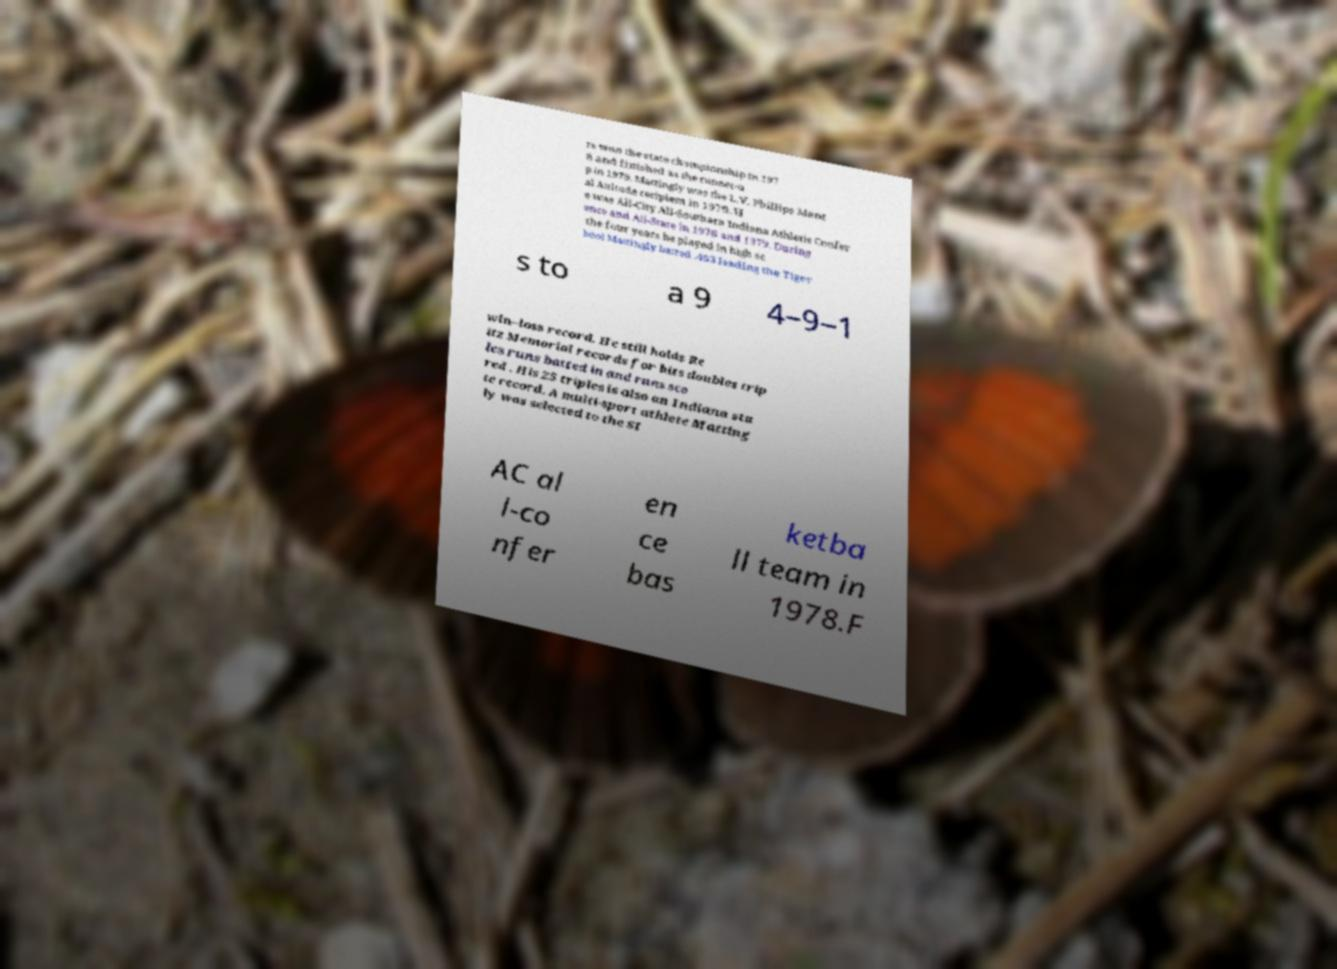For documentation purposes, I need the text within this image transcribed. Could you provide that? rs won the state championship in 197 8 and finished as the runner-u p in 1979. Mattingly was the L.V. Phillips Ment al Attitude recipient in 1979. H e was All-City All-Southern Indiana Athletic Confer ence and All-State in 1978 and 1979. During the four years he played in high sc hool Mattingly batted .463 leading the Tiger s to a 9 4–9–1 win–loss record. He still holds Re itz Memorial records for hits doubles trip les runs batted in and runs sco red . His 25 triples is also an Indiana sta te record. A multi-sport athlete Matting ly was selected to the SI AC al l-co nfer en ce bas ketba ll team in 1978.F 